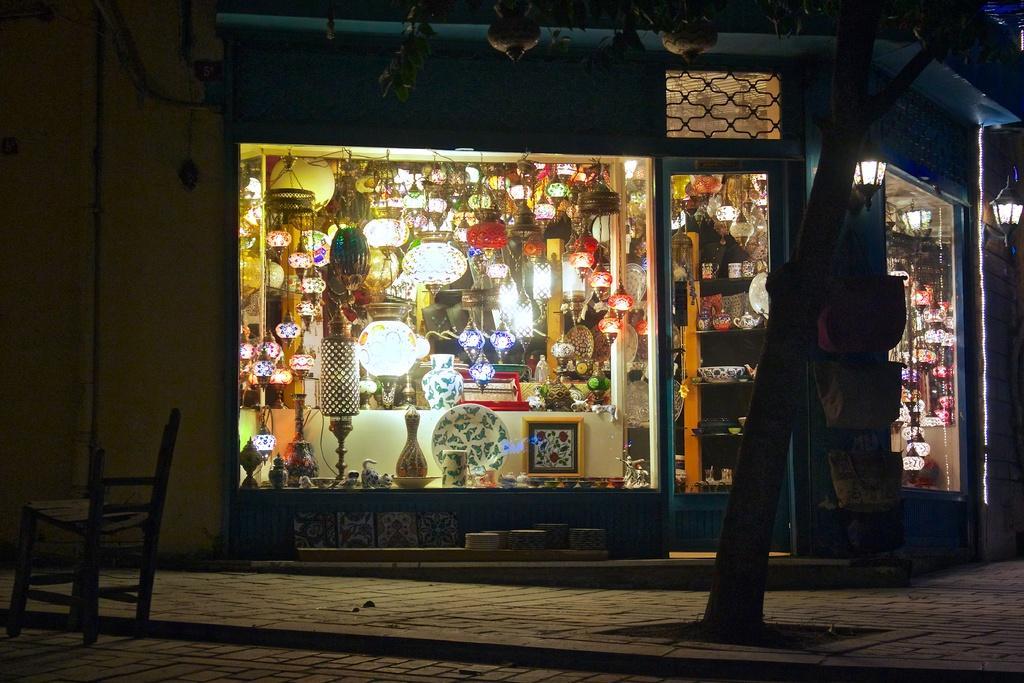Could you give a brief overview of what you see in this image? This image is taken outdoors. At the bottom of the image there is a floor. On the left side of the image there is an empty chair. In the middle of the image there is a house with walls and doors. There are a few lights. There are many paper lamps, lamps, jars and many things in the room. There is a tree. 